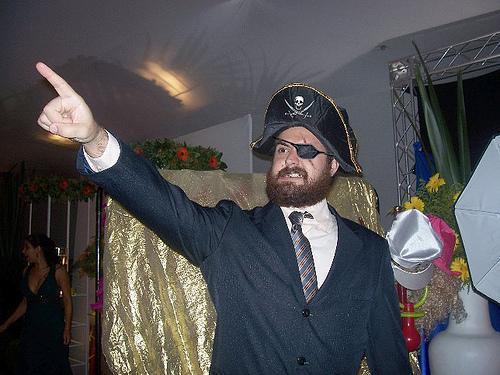How many people?
Give a very brief answer. 1. How many people are there?
Give a very brief answer. 2. 